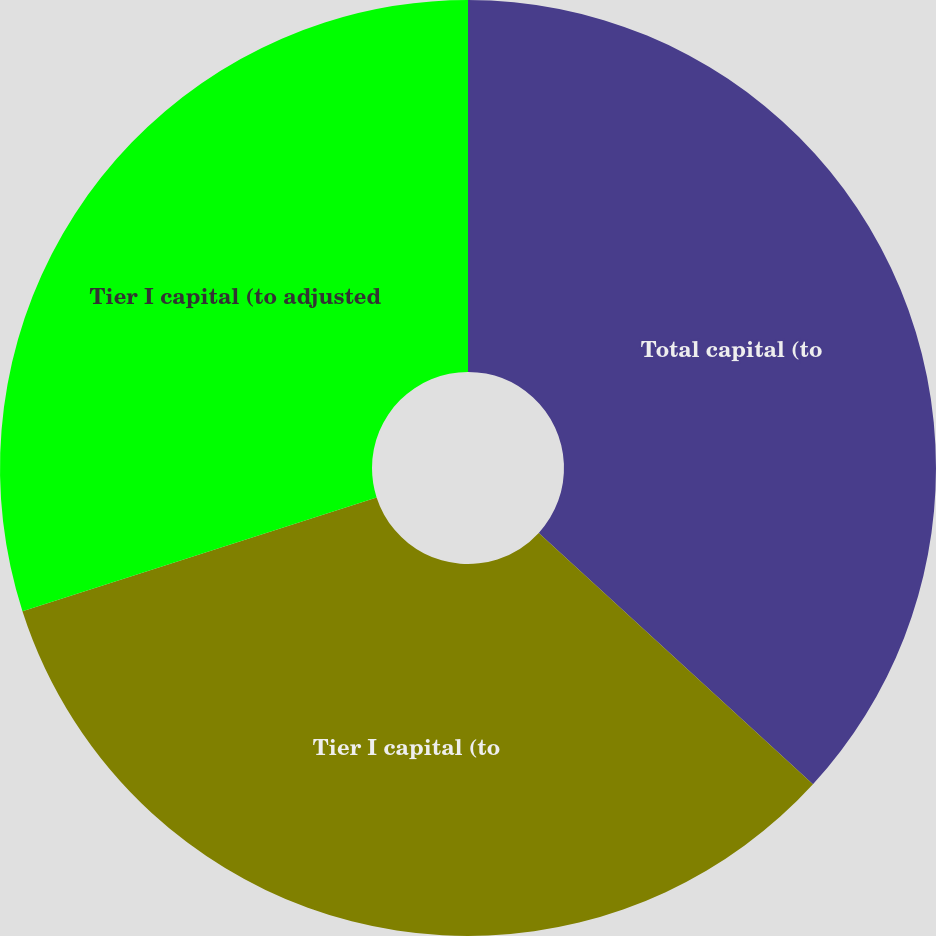Convert chart. <chart><loc_0><loc_0><loc_500><loc_500><pie_chart><fcel>Total capital (to<fcel>Tier I capital (to<fcel>Tier I capital (to adjusted<nl><fcel>36.81%<fcel>33.24%<fcel>29.95%<nl></chart> 